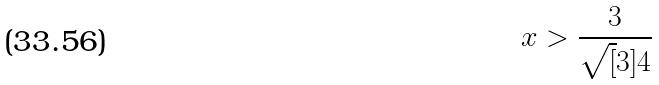<formula> <loc_0><loc_0><loc_500><loc_500>x > \frac { 3 } { \sqrt { [ } 3 ] { 4 } }</formula> 